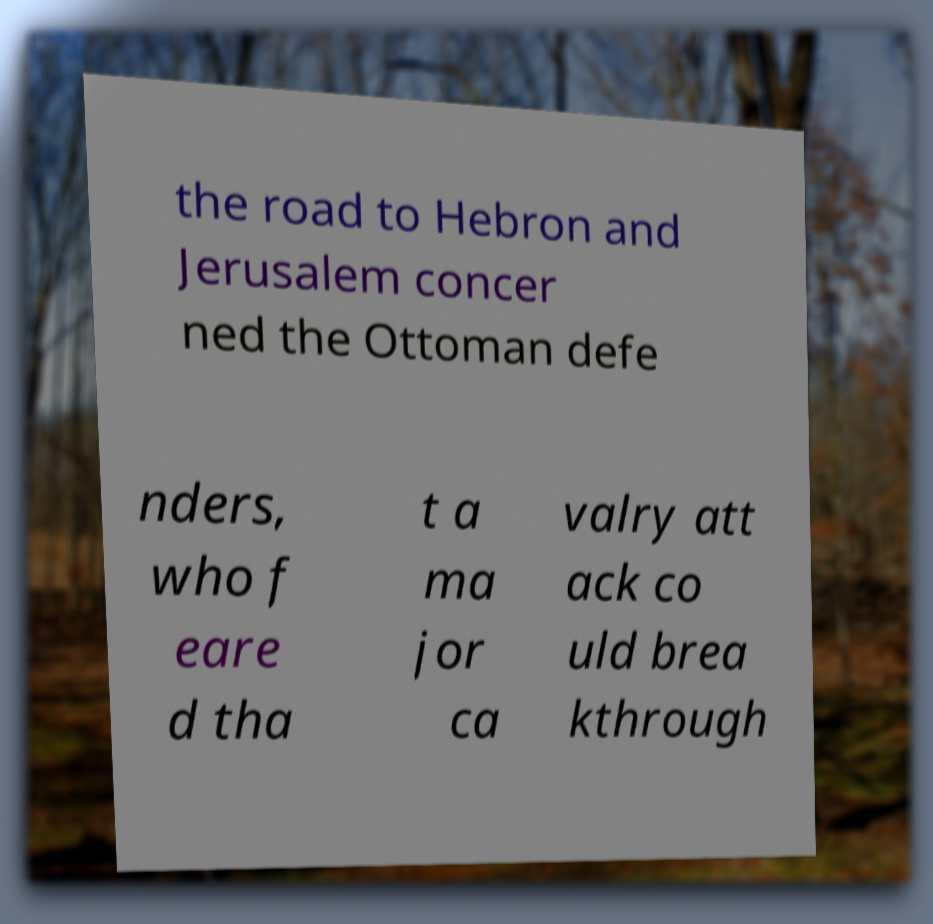There's text embedded in this image that I need extracted. Can you transcribe it verbatim? the road to Hebron and Jerusalem concer ned the Ottoman defe nders, who f eare d tha t a ma jor ca valry att ack co uld brea kthrough 